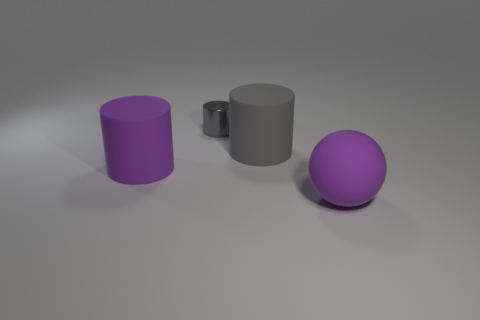Are there more tiny green shiny blocks than large matte spheres?
Give a very brief answer. No. What size is the purple matte object to the left of the large purple rubber thing in front of the large purple object that is on the left side of the purple rubber ball?
Your answer should be very brief. Large. Does the purple cylinder have the same size as the gray cylinder on the right side of the tiny thing?
Make the answer very short. Yes. Are there fewer small gray things that are in front of the metal object than large gray rubber things?
Ensure brevity in your answer.  Yes. How many metal cylinders have the same color as the large rubber ball?
Offer a terse response. 0. Are there fewer large purple matte cylinders than tiny blue objects?
Make the answer very short. No. Do the small gray cylinder and the sphere have the same material?
Keep it short and to the point. No. How many other objects are there of the same size as the gray shiny cylinder?
Keep it short and to the point. 0. What is the color of the tiny object on the left side of the matte object on the right side of the large gray cylinder?
Your response must be concise. Gray. What number of other objects are the same shape as the tiny metal thing?
Make the answer very short. 2. 